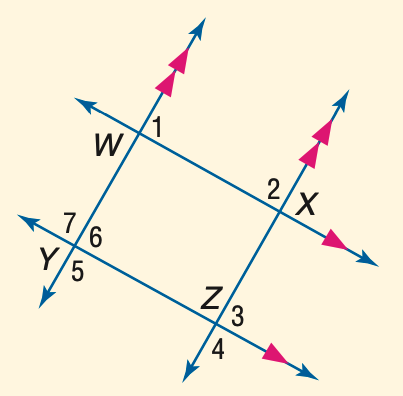Answer the mathemtical geometry problem and directly provide the correct option letter.
Question: In the figure, m \angle 1 = 53. Find the measure of \angle 2.
Choices: A: 97 B: 107 C: 117 D: 127 D 